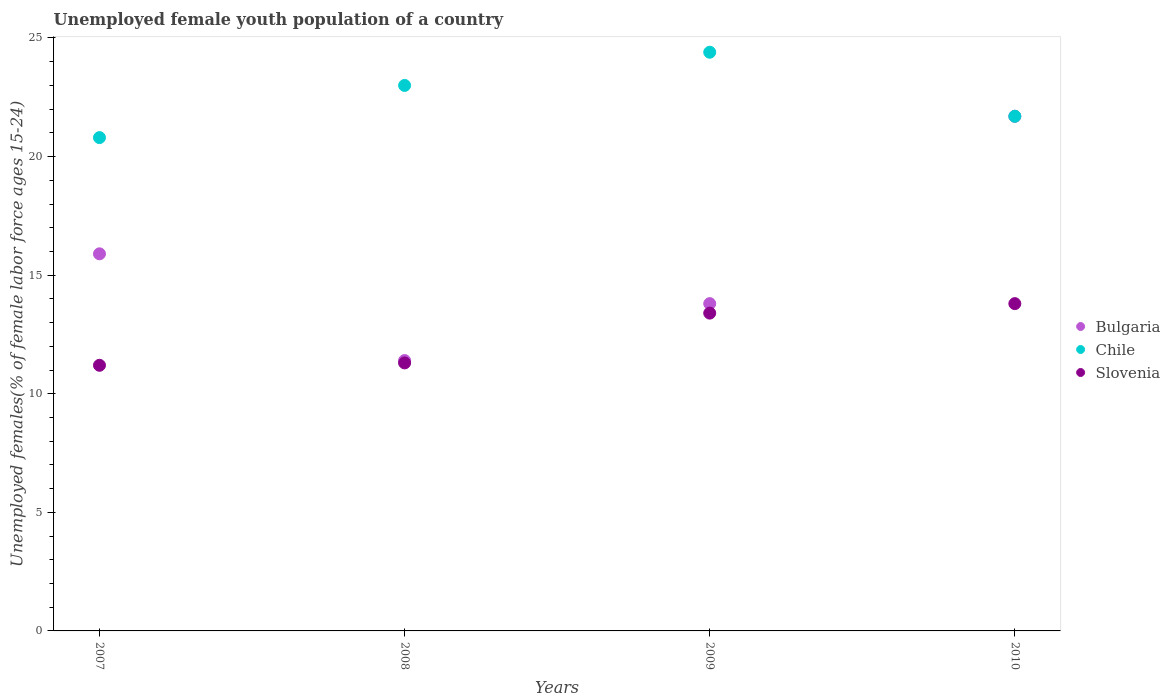Is the number of dotlines equal to the number of legend labels?
Make the answer very short. Yes. What is the percentage of unemployed female youth population in Slovenia in 2008?
Your response must be concise. 11.3. Across all years, what is the maximum percentage of unemployed female youth population in Chile?
Give a very brief answer. 24.4. Across all years, what is the minimum percentage of unemployed female youth population in Chile?
Your answer should be compact. 20.8. What is the total percentage of unemployed female youth population in Bulgaria in the graph?
Provide a short and direct response. 62.8. What is the difference between the percentage of unemployed female youth population in Chile in 2007 and that in 2008?
Make the answer very short. -2.2. What is the difference between the percentage of unemployed female youth population in Slovenia in 2008 and the percentage of unemployed female youth population in Bulgaria in 2007?
Provide a short and direct response. -4.6. What is the average percentage of unemployed female youth population in Chile per year?
Offer a terse response. 22.47. In the year 2007, what is the difference between the percentage of unemployed female youth population in Bulgaria and percentage of unemployed female youth population in Chile?
Your answer should be compact. -4.9. In how many years, is the percentage of unemployed female youth population in Slovenia greater than 19 %?
Ensure brevity in your answer.  0. What is the ratio of the percentage of unemployed female youth population in Chile in 2008 to that in 2010?
Give a very brief answer. 1.06. What is the difference between the highest and the second highest percentage of unemployed female youth population in Bulgaria?
Keep it short and to the point. 5.8. What is the difference between the highest and the lowest percentage of unemployed female youth population in Bulgaria?
Keep it short and to the point. 10.3. In how many years, is the percentage of unemployed female youth population in Slovenia greater than the average percentage of unemployed female youth population in Slovenia taken over all years?
Your response must be concise. 2. Is the sum of the percentage of unemployed female youth population in Bulgaria in 2008 and 2010 greater than the maximum percentage of unemployed female youth population in Slovenia across all years?
Your answer should be very brief. Yes. Is the percentage of unemployed female youth population in Bulgaria strictly greater than the percentage of unemployed female youth population in Slovenia over the years?
Provide a short and direct response. Yes. How many dotlines are there?
Give a very brief answer. 3. How many years are there in the graph?
Provide a succinct answer. 4. What is the difference between two consecutive major ticks on the Y-axis?
Offer a terse response. 5. Are the values on the major ticks of Y-axis written in scientific E-notation?
Give a very brief answer. No. Does the graph contain any zero values?
Your answer should be very brief. No. Where does the legend appear in the graph?
Keep it short and to the point. Center right. How many legend labels are there?
Your answer should be very brief. 3. What is the title of the graph?
Give a very brief answer. Unemployed female youth population of a country. Does "Bermuda" appear as one of the legend labels in the graph?
Your answer should be compact. No. What is the label or title of the Y-axis?
Provide a short and direct response. Unemployed females(% of female labor force ages 15-24). What is the Unemployed females(% of female labor force ages 15-24) in Bulgaria in 2007?
Make the answer very short. 15.9. What is the Unemployed females(% of female labor force ages 15-24) in Chile in 2007?
Make the answer very short. 20.8. What is the Unemployed females(% of female labor force ages 15-24) in Slovenia in 2007?
Your answer should be very brief. 11.2. What is the Unemployed females(% of female labor force ages 15-24) in Bulgaria in 2008?
Offer a terse response. 11.4. What is the Unemployed females(% of female labor force ages 15-24) in Slovenia in 2008?
Provide a short and direct response. 11.3. What is the Unemployed females(% of female labor force ages 15-24) of Bulgaria in 2009?
Offer a very short reply. 13.8. What is the Unemployed females(% of female labor force ages 15-24) in Chile in 2009?
Offer a terse response. 24.4. What is the Unemployed females(% of female labor force ages 15-24) in Slovenia in 2009?
Your answer should be very brief. 13.4. What is the Unemployed females(% of female labor force ages 15-24) in Bulgaria in 2010?
Offer a very short reply. 21.7. What is the Unemployed females(% of female labor force ages 15-24) in Chile in 2010?
Offer a very short reply. 21.7. What is the Unemployed females(% of female labor force ages 15-24) of Slovenia in 2010?
Make the answer very short. 13.8. Across all years, what is the maximum Unemployed females(% of female labor force ages 15-24) of Bulgaria?
Your answer should be compact. 21.7. Across all years, what is the maximum Unemployed females(% of female labor force ages 15-24) in Chile?
Provide a short and direct response. 24.4. Across all years, what is the maximum Unemployed females(% of female labor force ages 15-24) of Slovenia?
Offer a terse response. 13.8. Across all years, what is the minimum Unemployed females(% of female labor force ages 15-24) of Bulgaria?
Your answer should be compact. 11.4. Across all years, what is the minimum Unemployed females(% of female labor force ages 15-24) in Chile?
Your response must be concise. 20.8. Across all years, what is the minimum Unemployed females(% of female labor force ages 15-24) in Slovenia?
Keep it short and to the point. 11.2. What is the total Unemployed females(% of female labor force ages 15-24) of Bulgaria in the graph?
Provide a short and direct response. 62.8. What is the total Unemployed females(% of female labor force ages 15-24) of Chile in the graph?
Keep it short and to the point. 89.9. What is the total Unemployed females(% of female labor force ages 15-24) in Slovenia in the graph?
Provide a short and direct response. 49.7. What is the difference between the Unemployed females(% of female labor force ages 15-24) in Chile in 2007 and that in 2008?
Keep it short and to the point. -2.2. What is the difference between the Unemployed females(% of female labor force ages 15-24) in Bulgaria in 2007 and that in 2009?
Keep it short and to the point. 2.1. What is the difference between the Unemployed females(% of female labor force ages 15-24) of Chile in 2007 and that in 2009?
Give a very brief answer. -3.6. What is the difference between the Unemployed females(% of female labor force ages 15-24) in Bulgaria in 2007 and that in 2010?
Offer a terse response. -5.8. What is the difference between the Unemployed females(% of female labor force ages 15-24) of Bulgaria in 2008 and that in 2009?
Ensure brevity in your answer.  -2.4. What is the difference between the Unemployed females(% of female labor force ages 15-24) of Chile in 2008 and that in 2010?
Ensure brevity in your answer.  1.3. What is the difference between the Unemployed females(% of female labor force ages 15-24) in Bulgaria in 2009 and that in 2010?
Your answer should be compact. -7.9. What is the difference between the Unemployed females(% of female labor force ages 15-24) in Chile in 2009 and that in 2010?
Your answer should be very brief. 2.7. What is the difference between the Unemployed females(% of female labor force ages 15-24) of Slovenia in 2009 and that in 2010?
Provide a short and direct response. -0.4. What is the difference between the Unemployed females(% of female labor force ages 15-24) in Bulgaria in 2007 and the Unemployed females(% of female labor force ages 15-24) in Chile in 2008?
Keep it short and to the point. -7.1. What is the difference between the Unemployed females(% of female labor force ages 15-24) of Bulgaria in 2007 and the Unemployed females(% of female labor force ages 15-24) of Slovenia in 2008?
Give a very brief answer. 4.6. What is the difference between the Unemployed females(% of female labor force ages 15-24) in Bulgaria in 2007 and the Unemployed females(% of female labor force ages 15-24) in Chile in 2009?
Your answer should be very brief. -8.5. What is the difference between the Unemployed females(% of female labor force ages 15-24) in Chile in 2007 and the Unemployed females(% of female labor force ages 15-24) in Slovenia in 2009?
Give a very brief answer. 7.4. What is the difference between the Unemployed females(% of female labor force ages 15-24) in Chile in 2007 and the Unemployed females(% of female labor force ages 15-24) in Slovenia in 2010?
Ensure brevity in your answer.  7. What is the difference between the Unemployed females(% of female labor force ages 15-24) of Chile in 2008 and the Unemployed females(% of female labor force ages 15-24) of Slovenia in 2009?
Make the answer very short. 9.6. What is the difference between the Unemployed females(% of female labor force ages 15-24) of Bulgaria in 2008 and the Unemployed females(% of female labor force ages 15-24) of Slovenia in 2010?
Offer a terse response. -2.4. What is the difference between the Unemployed females(% of female labor force ages 15-24) of Bulgaria in 2009 and the Unemployed females(% of female labor force ages 15-24) of Chile in 2010?
Provide a short and direct response. -7.9. What is the difference between the Unemployed females(% of female labor force ages 15-24) in Bulgaria in 2009 and the Unemployed females(% of female labor force ages 15-24) in Slovenia in 2010?
Provide a succinct answer. 0. What is the average Unemployed females(% of female labor force ages 15-24) in Bulgaria per year?
Offer a very short reply. 15.7. What is the average Unemployed females(% of female labor force ages 15-24) in Chile per year?
Keep it short and to the point. 22.48. What is the average Unemployed females(% of female labor force ages 15-24) in Slovenia per year?
Provide a short and direct response. 12.43. In the year 2008, what is the difference between the Unemployed females(% of female labor force ages 15-24) in Bulgaria and Unemployed females(% of female labor force ages 15-24) in Chile?
Make the answer very short. -11.6. In the year 2008, what is the difference between the Unemployed females(% of female labor force ages 15-24) of Bulgaria and Unemployed females(% of female labor force ages 15-24) of Slovenia?
Ensure brevity in your answer.  0.1. In the year 2009, what is the difference between the Unemployed females(% of female labor force ages 15-24) of Bulgaria and Unemployed females(% of female labor force ages 15-24) of Slovenia?
Offer a terse response. 0.4. In the year 2009, what is the difference between the Unemployed females(% of female labor force ages 15-24) in Chile and Unemployed females(% of female labor force ages 15-24) in Slovenia?
Provide a short and direct response. 11. In the year 2010, what is the difference between the Unemployed females(% of female labor force ages 15-24) in Bulgaria and Unemployed females(% of female labor force ages 15-24) in Chile?
Give a very brief answer. 0. In the year 2010, what is the difference between the Unemployed females(% of female labor force ages 15-24) in Bulgaria and Unemployed females(% of female labor force ages 15-24) in Slovenia?
Make the answer very short. 7.9. What is the ratio of the Unemployed females(% of female labor force ages 15-24) of Bulgaria in 2007 to that in 2008?
Provide a short and direct response. 1.39. What is the ratio of the Unemployed females(% of female labor force ages 15-24) of Chile in 2007 to that in 2008?
Ensure brevity in your answer.  0.9. What is the ratio of the Unemployed females(% of female labor force ages 15-24) of Bulgaria in 2007 to that in 2009?
Offer a very short reply. 1.15. What is the ratio of the Unemployed females(% of female labor force ages 15-24) in Chile in 2007 to that in 2009?
Your response must be concise. 0.85. What is the ratio of the Unemployed females(% of female labor force ages 15-24) of Slovenia in 2007 to that in 2009?
Offer a terse response. 0.84. What is the ratio of the Unemployed females(% of female labor force ages 15-24) of Bulgaria in 2007 to that in 2010?
Offer a very short reply. 0.73. What is the ratio of the Unemployed females(% of female labor force ages 15-24) of Chile in 2007 to that in 2010?
Provide a succinct answer. 0.96. What is the ratio of the Unemployed females(% of female labor force ages 15-24) in Slovenia in 2007 to that in 2010?
Offer a terse response. 0.81. What is the ratio of the Unemployed females(% of female labor force ages 15-24) of Bulgaria in 2008 to that in 2009?
Give a very brief answer. 0.83. What is the ratio of the Unemployed females(% of female labor force ages 15-24) of Chile in 2008 to that in 2009?
Offer a very short reply. 0.94. What is the ratio of the Unemployed females(% of female labor force ages 15-24) in Slovenia in 2008 to that in 2009?
Offer a very short reply. 0.84. What is the ratio of the Unemployed females(% of female labor force ages 15-24) of Bulgaria in 2008 to that in 2010?
Offer a very short reply. 0.53. What is the ratio of the Unemployed females(% of female labor force ages 15-24) in Chile in 2008 to that in 2010?
Your response must be concise. 1.06. What is the ratio of the Unemployed females(% of female labor force ages 15-24) of Slovenia in 2008 to that in 2010?
Provide a succinct answer. 0.82. What is the ratio of the Unemployed females(% of female labor force ages 15-24) in Bulgaria in 2009 to that in 2010?
Your answer should be very brief. 0.64. What is the ratio of the Unemployed females(% of female labor force ages 15-24) of Chile in 2009 to that in 2010?
Make the answer very short. 1.12. What is the ratio of the Unemployed females(% of female labor force ages 15-24) in Slovenia in 2009 to that in 2010?
Provide a short and direct response. 0.97. What is the difference between the highest and the second highest Unemployed females(% of female labor force ages 15-24) in Bulgaria?
Your answer should be compact. 5.8. What is the difference between the highest and the lowest Unemployed females(% of female labor force ages 15-24) of Chile?
Your response must be concise. 3.6. 